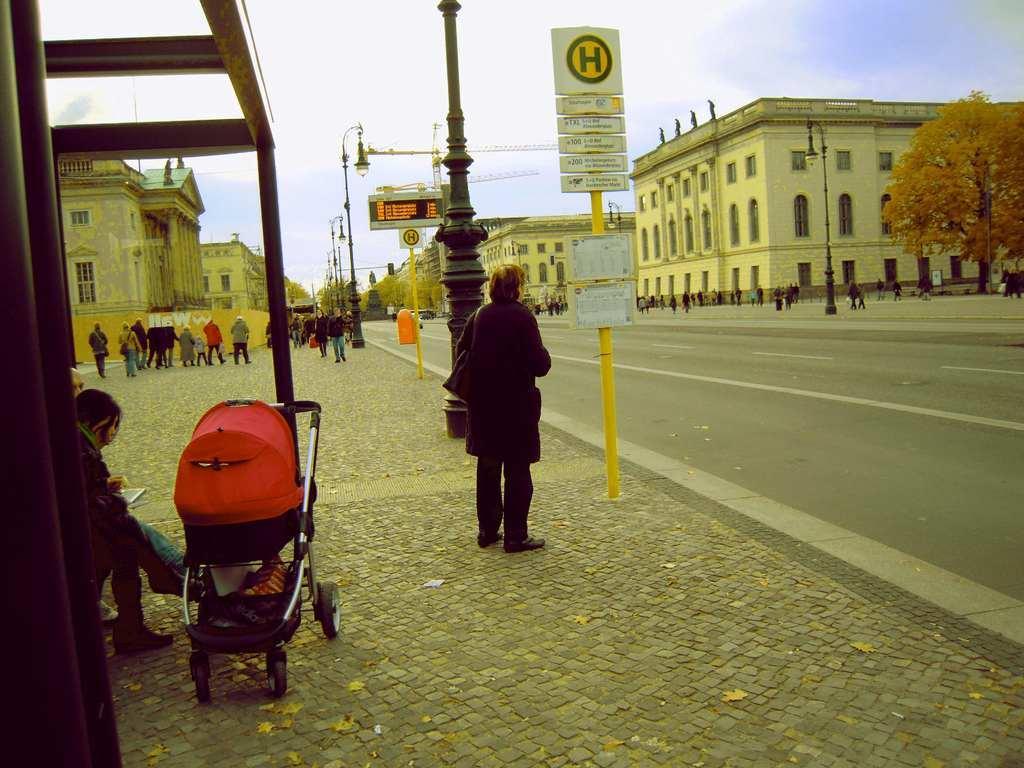Can you describe this image briefly? As we can see in the image there are few people here and there, buildings, street lamps, sign pole and sky. 